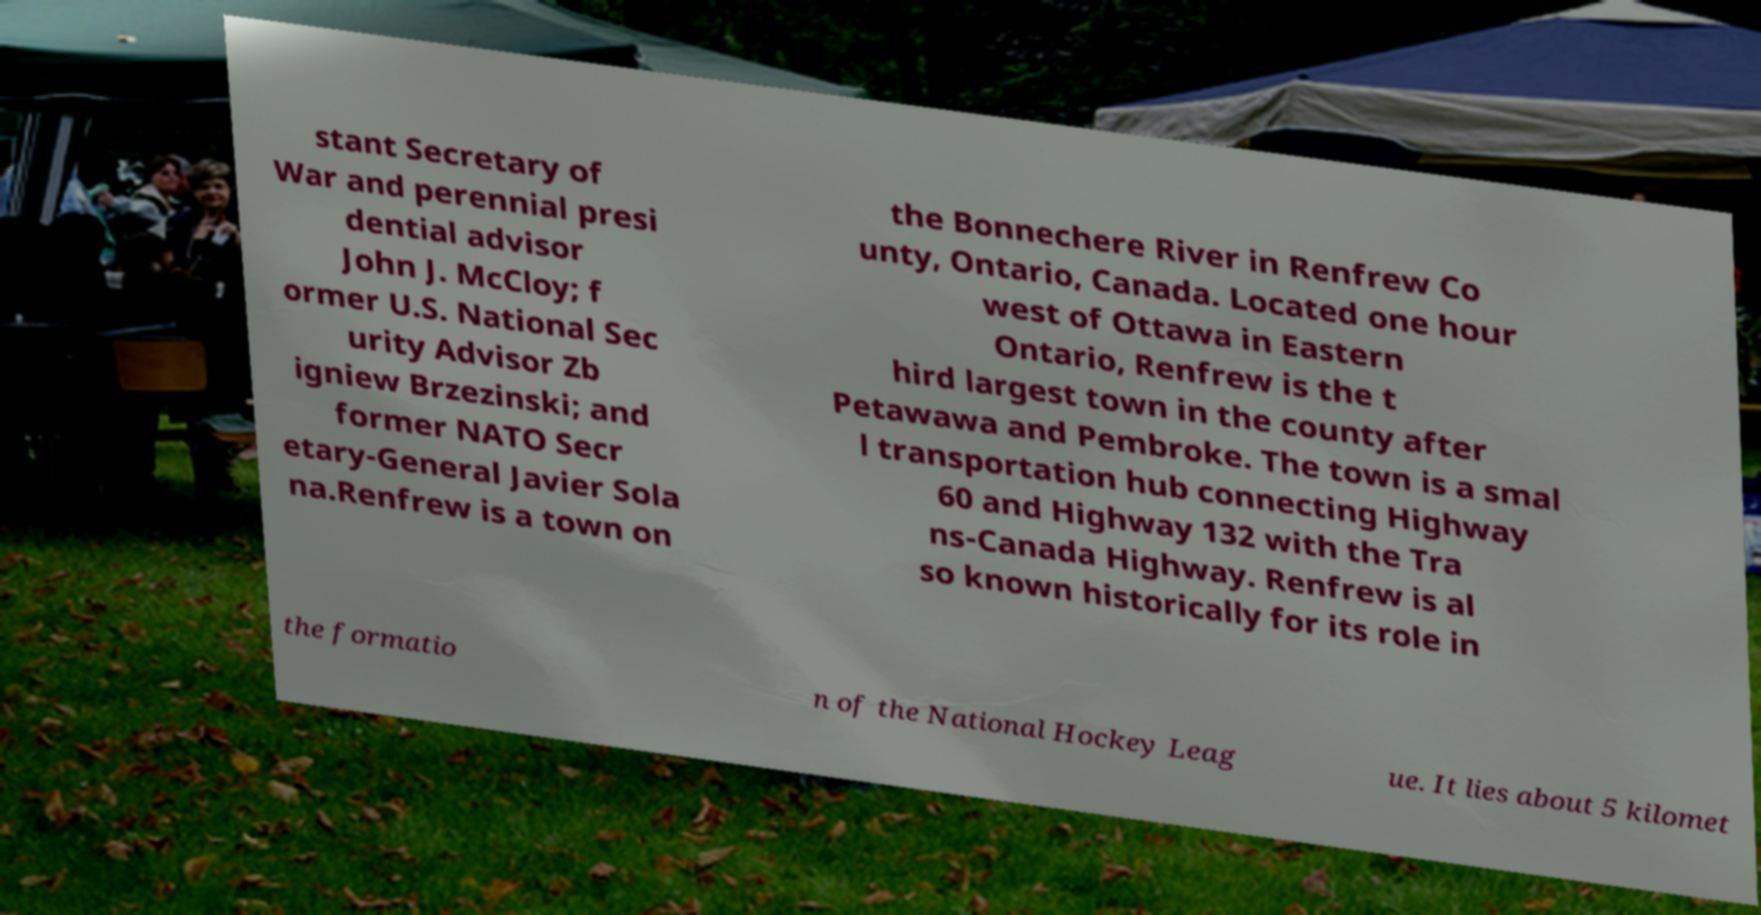Can you read and provide the text displayed in the image?This photo seems to have some interesting text. Can you extract and type it out for me? stant Secretary of War and perennial presi dential advisor John J. McCloy; f ormer U.S. National Sec urity Advisor Zb igniew Brzezinski; and former NATO Secr etary-General Javier Sola na.Renfrew is a town on the Bonnechere River in Renfrew Co unty, Ontario, Canada. Located one hour west of Ottawa in Eastern Ontario, Renfrew is the t hird largest town in the county after Petawawa and Pembroke. The town is a smal l transportation hub connecting Highway 60 and Highway 132 with the Tra ns-Canada Highway. Renfrew is al so known historically for its role in the formatio n of the National Hockey Leag ue. It lies about 5 kilomet 